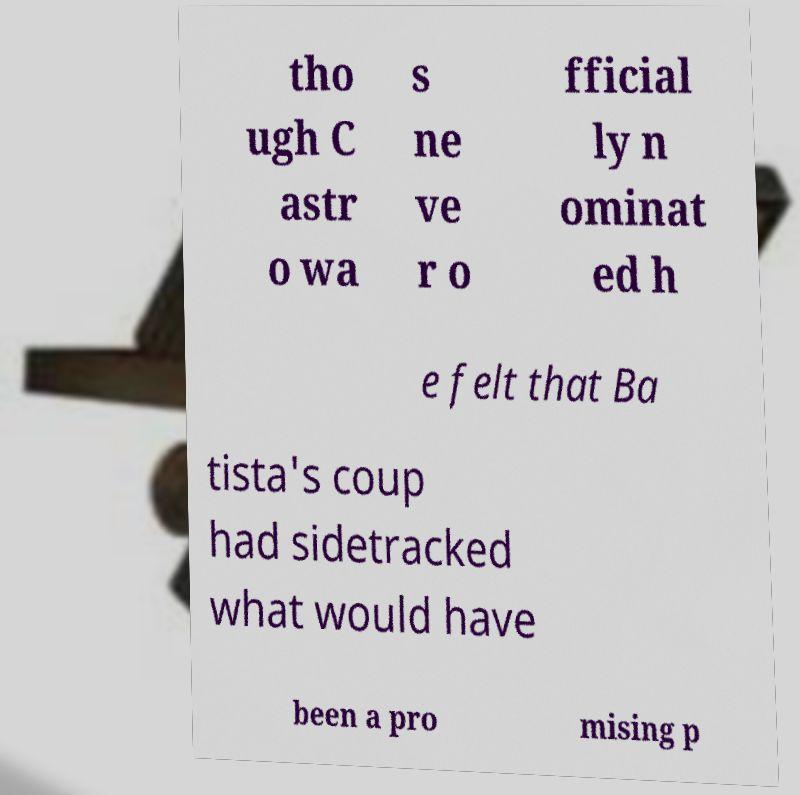I need the written content from this picture converted into text. Can you do that? tho ugh C astr o wa s ne ve r o fficial ly n ominat ed h e felt that Ba tista's coup had sidetracked what would have been a pro mising p 